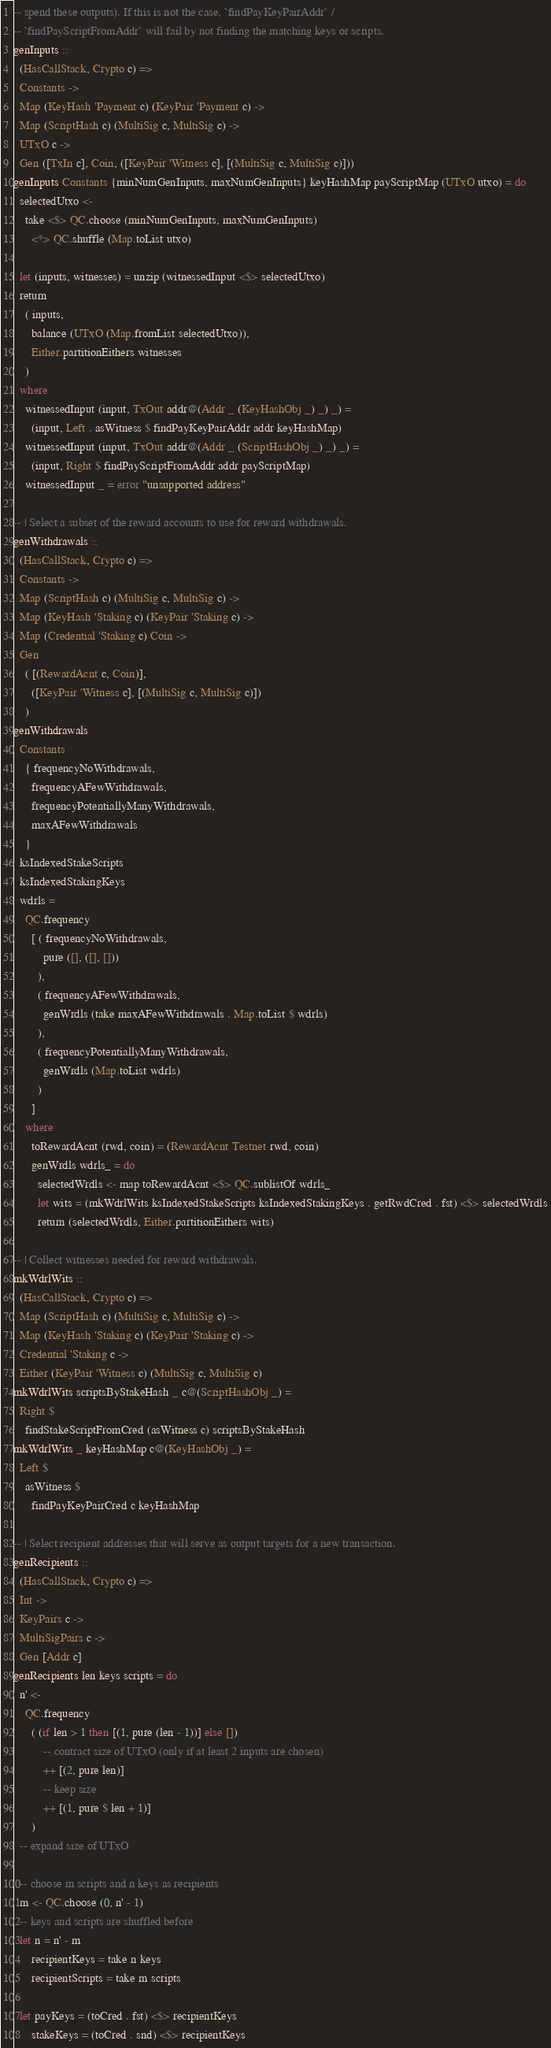Convert code to text. <code><loc_0><loc_0><loc_500><loc_500><_Haskell_>-- spend these outputs). If this is not the case, `findPayKeyPairAddr` /
-- `findPayScriptFromAddr` will fail by not finding the matching keys or scripts.
genInputs ::
  (HasCallStack, Crypto c) =>
  Constants ->
  Map (KeyHash 'Payment c) (KeyPair 'Payment c) ->
  Map (ScriptHash c) (MultiSig c, MultiSig c) ->
  UTxO c ->
  Gen ([TxIn c], Coin, ([KeyPair 'Witness c], [(MultiSig c, MultiSig c)]))
genInputs Constants {minNumGenInputs, maxNumGenInputs} keyHashMap payScriptMap (UTxO utxo) = do
  selectedUtxo <-
    take <$> QC.choose (minNumGenInputs, maxNumGenInputs)
      <*> QC.shuffle (Map.toList utxo)

  let (inputs, witnesses) = unzip (witnessedInput <$> selectedUtxo)
  return
    ( inputs,
      balance (UTxO (Map.fromList selectedUtxo)),
      Either.partitionEithers witnesses
    )
  where
    witnessedInput (input, TxOut addr@(Addr _ (KeyHashObj _) _) _) =
      (input, Left . asWitness $ findPayKeyPairAddr addr keyHashMap)
    witnessedInput (input, TxOut addr@(Addr _ (ScriptHashObj _) _) _) =
      (input, Right $ findPayScriptFromAddr addr payScriptMap)
    witnessedInput _ = error "unsupported address"

-- | Select a subset of the reward accounts to use for reward withdrawals.
genWithdrawals ::
  (HasCallStack, Crypto c) =>
  Constants ->
  Map (ScriptHash c) (MultiSig c, MultiSig c) ->
  Map (KeyHash 'Staking c) (KeyPair 'Staking c) ->
  Map (Credential 'Staking c) Coin ->
  Gen
    ( [(RewardAcnt c, Coin)],
      ([KeyPair 'Witness c], [(MultiSig c, MultiSig c)])
    )
genWithdrawals
  Constants
    { frequencyNoWithdrawals,
      frequencyAFewWithdrawals,
      frequencyPotentiallyManyWithdrawals,
      maxAFewWithdrawals
    }
  ksIndexedStakeScripts
  ksIndexedStakingKeys
  wdrls =
    QC.frequency
      [ ( frequencyNoWithdrawals,
          pure ([], ([], []))
        ),
        ( frequencyAFewWithdrawals,
          genWrdls (take maxAFewWithdrawals . Map.toList $ wdrls)
        ),
        ( frequencyPotentiallyManyWithdrawals,
          genWrdls (Map.toList wdrls)
        )
      ]
    where
      toRewardAcnt (rwd, coin) = (RewardAcnt Testnet rwd, coin)
      genWrdls wdrls_ = do
        selectedWrdls <- map toRewardAcnt <$> QC.sublistOf wdrls_
        let wits = (mkWdrlWits ksIndexedStakeScripts ksIndexedStakingKeys . getRwdCred . fst) <$> selectedWrdls
        return (selectedWrdls, Either.partitionEithers wits)

-- | Collect witnesses needed for reward withdrawals.
mkWdrlWits ::
  (HasCallStack, Crypto c) =>
  Map (ScriptHash c) (MultiSig c, MultiSig c) ->
  Map (KeyHash 'Staking c) (KeyPair 'Staking c) ->
  Credential 'Staking c ->
  Either (KeyPair 'Witness c) (MultiSig c, MultiSig c)
mkWdrlWits scriptsByStakeHash _ c@(ScriptHashObj _) =
  Right $
    findStakeScriptFromCred (asWitness c) scriptsByStakeHash
mkWdrlWits _ keyHashMap c@(KeyHashObj _) =
  Left $
    asWitness $
      findPayKeyPairCred c keyHashMap

-- | Select recipient addresses that will serve as output targets for a new transaction.
genRecipients ::
  (HasCallStack, Crypto c) =>
  Int ->
  KeyPairs c ->
  MultiSigPairs c ->
  Gen [Addr c]
genRecipients len keys scripts = do
  n' <-
    QC.frequency
      ( (if len > 1 then [(1, pure (len - 1))] else [])
          -- contract size of UTxO (only if at least 2 inputs are chosen)
          ++ [(2, pure len)]
          -- keep size
          ++ [(1, pure $ len + 1)]
      )
  -- expand size of UTxO

  -- choose m scripts and n keys as recipients
  m <- QC.choose (0, n' - 1)
  -- keys and scripts are shuffled before
  let n = n' - m
      recipientKeys = take n keys
      recipientScripts = take m scripts

  let payKeys = (toCred . fst) <$> recipientKeys
      stakeKeys = (toCred . snd) <$> recipientKeys</code> 